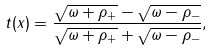<formula> <loc_0><loc_0><loc_500><loc_500>t ( x ) = { \frac { \sqrt { \omega + \rho _ { + } } - \sqrt { \omega - \rho _ { - } } } { \sqrt { \omega + \rho _ { + } } + \sqrt { \omega - \rho _ { - } } } } ,</formula> 